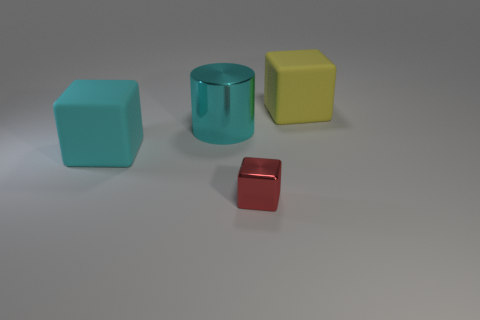What number of other things are the same size as the red metallic thing? Based on the image, it's not possible to determine if any item is exactly the same size as the red metallic object without precise measurements. However, visually, none of the other objects appear to be the exact same size. 